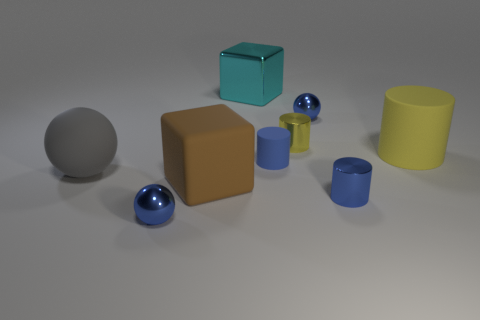Subtract 1 cylinders. How many cylinders are left? 3 Subtract all small blue metallic cylinders. How many cylinders are left? 3 Subtract all brown cylinders. Subtract all green cubes. How many cylinders are left? 4 Subtract all spheres. How many objects are left? 6 Subtract 0 gray cubes. How many objects are left? 9 Subtract all big brown metallic things. Subtract all blue metal objects. How many objects are left? 6 Add 1 big yellow rubber objects. How many big yellow rubber objects are left? 2 Add 9 rubber spheres. How many rubber spheres exist? 10 